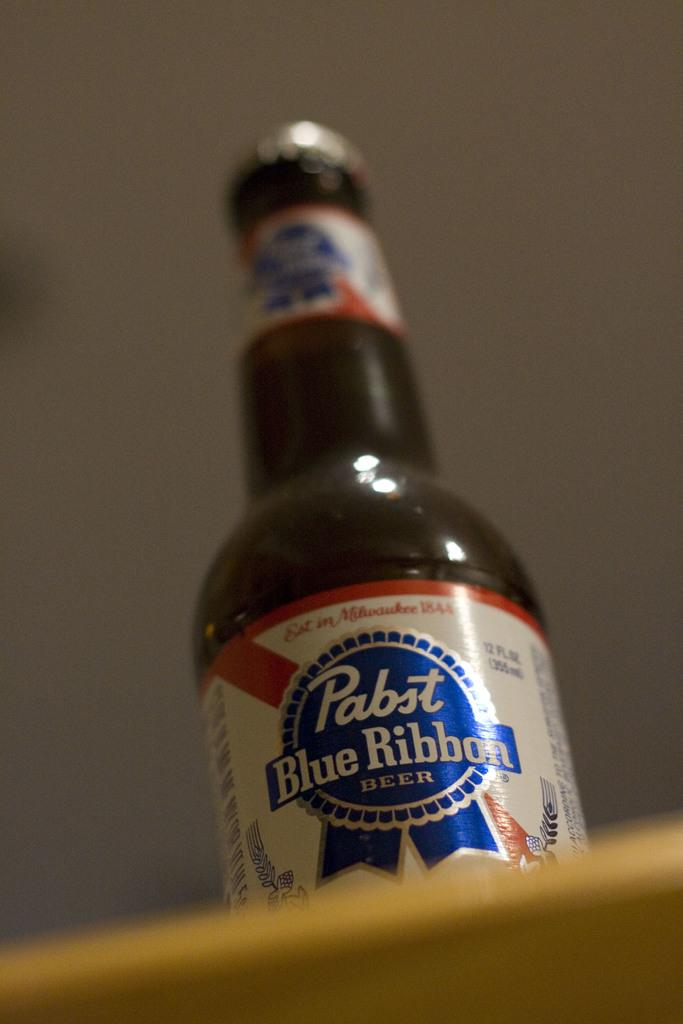What object can be seen in the image? There is a bottle in the image. What is on the bottle? The bottle has a sticker on it. Where is the bottle located? The bottle is placed on a platform. How many slices of pie are on the bottle in the image? There is no pie present in the image; it only features a bottle with a sticker on it. 